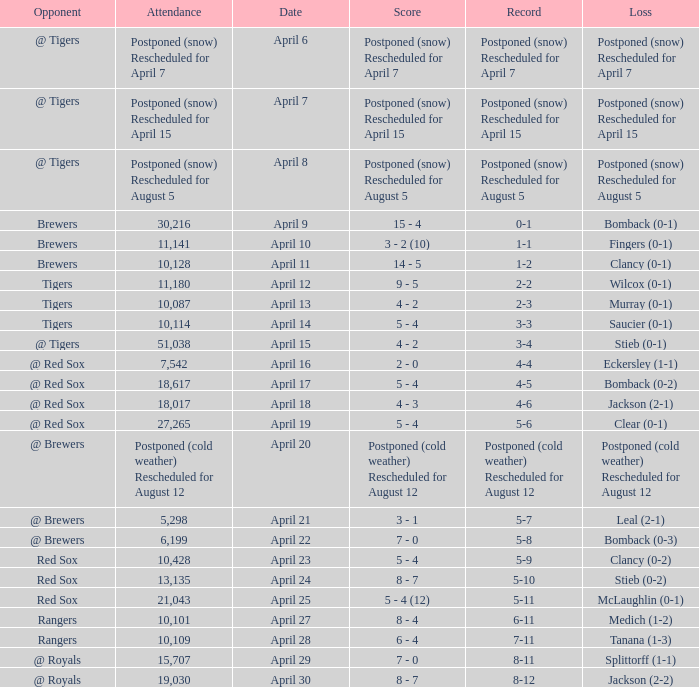What is the record for the game with an attendance of 11,141? 1-1. 